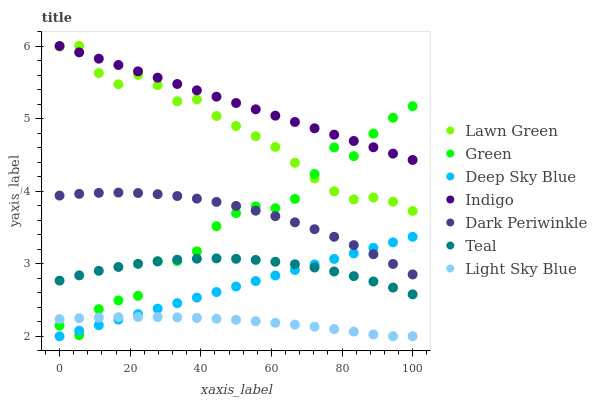Does Light Sky Blue have the minimum area under the curve?
Answer yes or no. Yes. Does Indigo have the maximum area under the curve?
Answer yes or no. Yes. Does Deep Sky Blue have the minimum area under the curve?
Answer yes or no. No. Does Deep Sky Blue have the maximum area under the curve?
Answer yes or no. No. Is Deep Sky Blue the smoothest?
Answer yes or no. Yes. Is Green the roughest?
Answer yes or no. Yes. Is Indigo the smoothest?
Answer yes or no. No. Is Indigo the roughest?
Answer yes or no. No. Does Deep Sky Blue have the lowest value?
Answer yes or no. Yes. Does Indigo have the lowest value?
Answer yes or no. No. Does Indigo have the highest value?
Answer yes or no. Yes. Does Deep Sky Blue have the highest value?
Answer yes or no. No. Is Deep Sky Blue less than Lawn Green?
Answer yes or no. Yes. Is Lawn Green greater than Light Sky Blue?
Answer yes or no. Yes. Does Teal intersect Deep Sky Blue?
Answer yes or no. Yes. Is Teal less than Deep Sky Blue?
Answer yes or no. No. Is Teal greater than Deep Sky Blue?
Answer yes or no. No. Does Deep Sky Blue intersect Lawn Green?
Answer yes or no. No. 